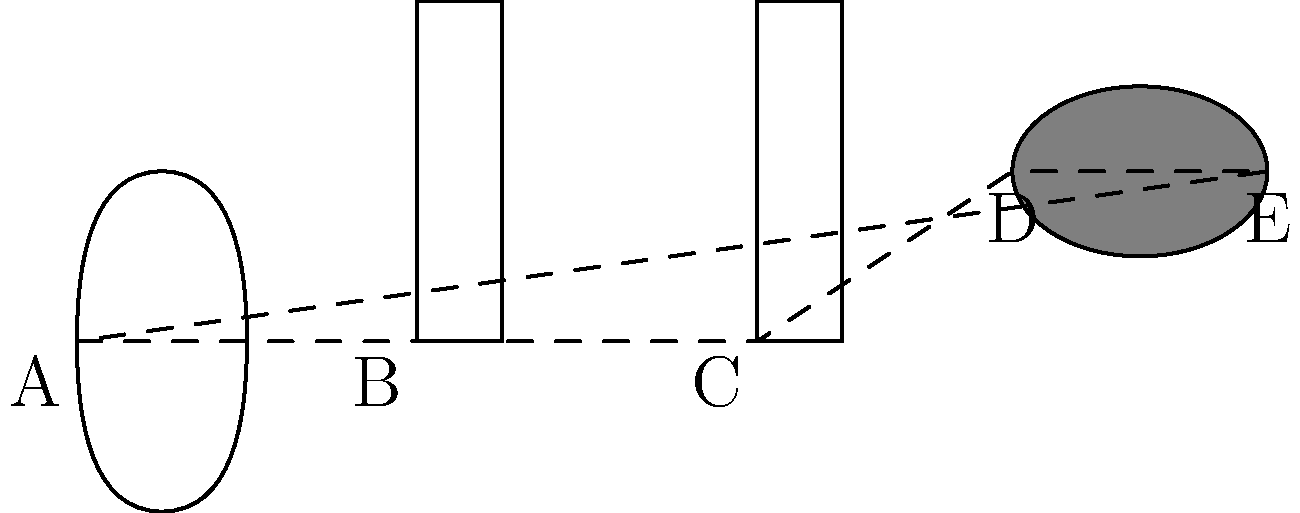In a creative digital marketing campaign for a classical music artist, you've designed a logo using various musical notes. The logo is formed by a treble clef (represented by a circular shape), a quarter note, a half note, and a whole note, arranged as shown in the figure. If the perimeter of the treble clef is 6 cm, the height of the quarter and half notes is 2 cm, and the whole note is an ellipse with a major axis of 1.5 cm, calculate the perimeter of the shape ABCDE that encloses all these musical symbols. Let's break this down step-by-step:

1) For segment AB:
   The width of the treble clef is 1 cm (given that its perimeter is 6 cm, assuming it's roughly circular).
   AB = 2 cm

2) For segment BC:
   This is the distance between the quarter note and half note.
   BC = 2 cm

3) For segment CD:
   This is half the width of the half note plus half the major axis of the whole note.
   CD = 0.5/2 + 1.5/2 = 0.25 + 0.75 = 1 cm

4) For segment DE:
   This is half the major axis of the whole note.
   DE = 1.5/2 = 0.75 cm

5) For segment EA:
   This is the distance from the end of the whole note to the start of the treble clef.
   EA = 7 - 1 = 6 cm (total width) - 1 cm (width of treble clef) = 5 cm

6) Total perimeter:
   $$P = AB + BC + CD + DE + EA$$
   $$P = 2 + 2 + 1 + 0.75 + 5 = 10.75 \text{ cm}$$

Therefore, the perimeter of the shape ABCDE is 10.75 cm.
Answer: 10.75 cm 